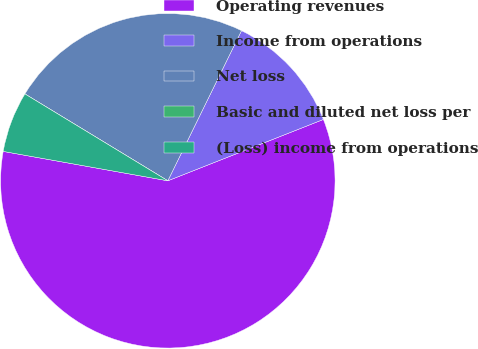Convert chart to OTSL. <chart><loc_0><loc_0><loc_500><loc_500><pie_chart><fcel>Operating revenues<fcel>Income from operations<fcel>Net loss<fcel>Basic and diluted net loss per<fcel>(Loss) income from operations<nl><fcel>58.79%<fcel>11.76%<fcel>23.57%<fcel>0.0%<fcel>5.88%<nl></chart> 